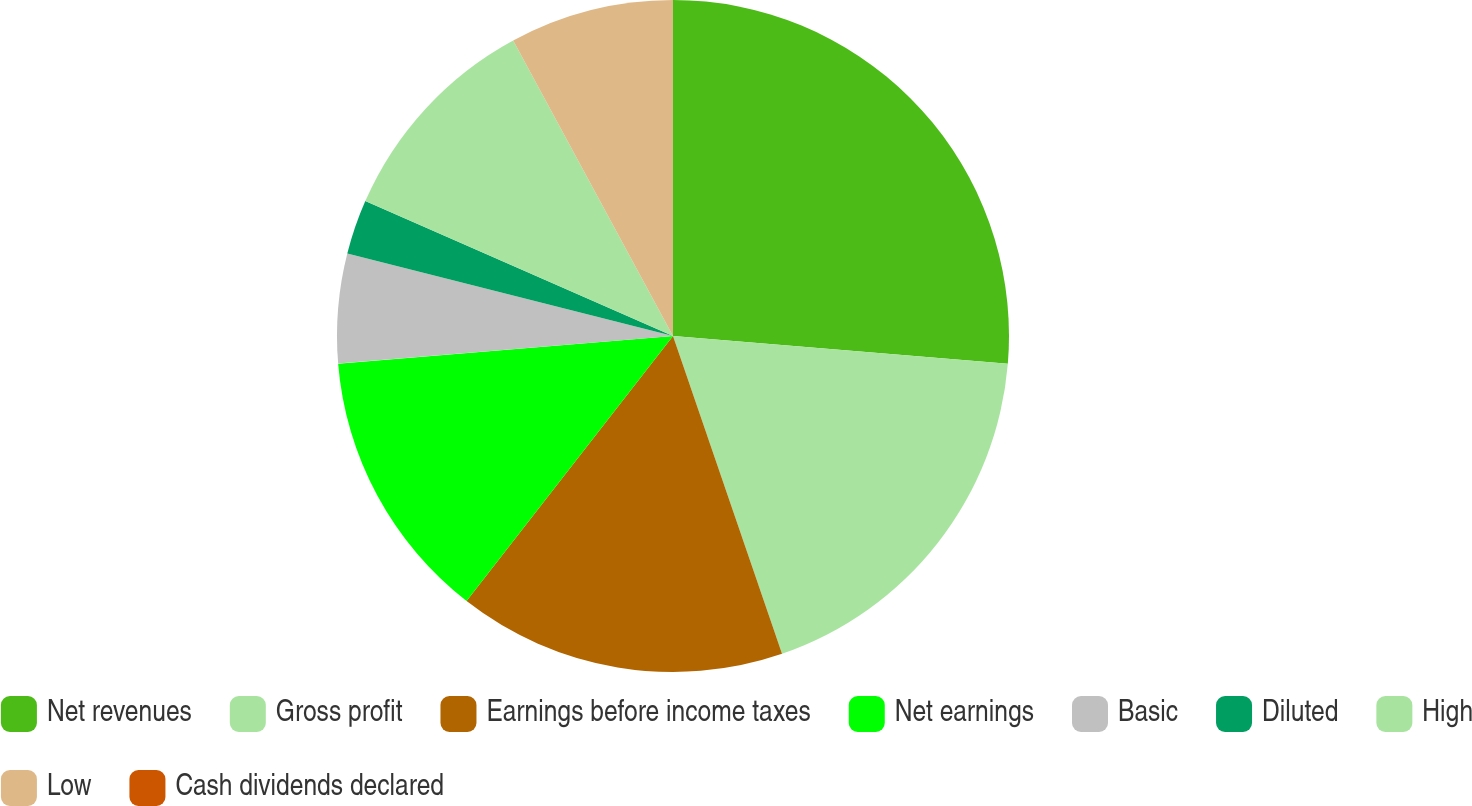Convert chart. <chart><loc_0><loc_0><loc_500><loc_500><pie_chart><fcel>Net revenues<fcel>Gross profit<fcel>Earnings before income taxes<fcel>Net earnings<fcel>Basic<fcel>Diluted<fcel>High<fcel>Low<fcel>Cash dividends declared<nl><fcel>26.32%<fcel>18.42%<fcel>15.79%<fcel>13.16%<fcel>5.26%<fcel>2.63%<fcel>10.53%<fcel>7.89%<fcel>0.0%<nl></chart> 